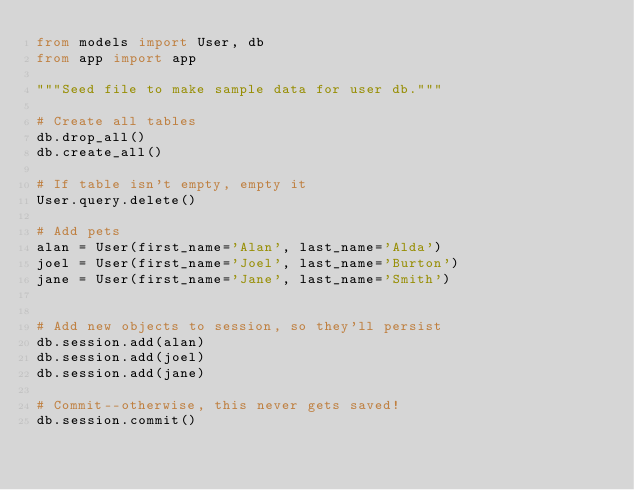<code> <loc_0><loc_0><loc_500><loc_500><_Python_>from models import User, db
from app import app

"""Seed file to make sample data for user db."""

# Create all tables
db.drop_all()
db.create_all()

# If table isn't empty, empty it
User.query.delete()

# Add pets
alan = User(first_name='Alan', last_name='Alda')
joel = User(first_name='Joel', last_name='Burton')
jane = User(first_name='Jane', last_name='Smith')


# Add new objects to session, so they'll persist
db.session.add(alan)
db.session.add(joel)
db.session.add(jane)

# Commit--otherwise, this never gets saved!
db.session.commit()
</code> 